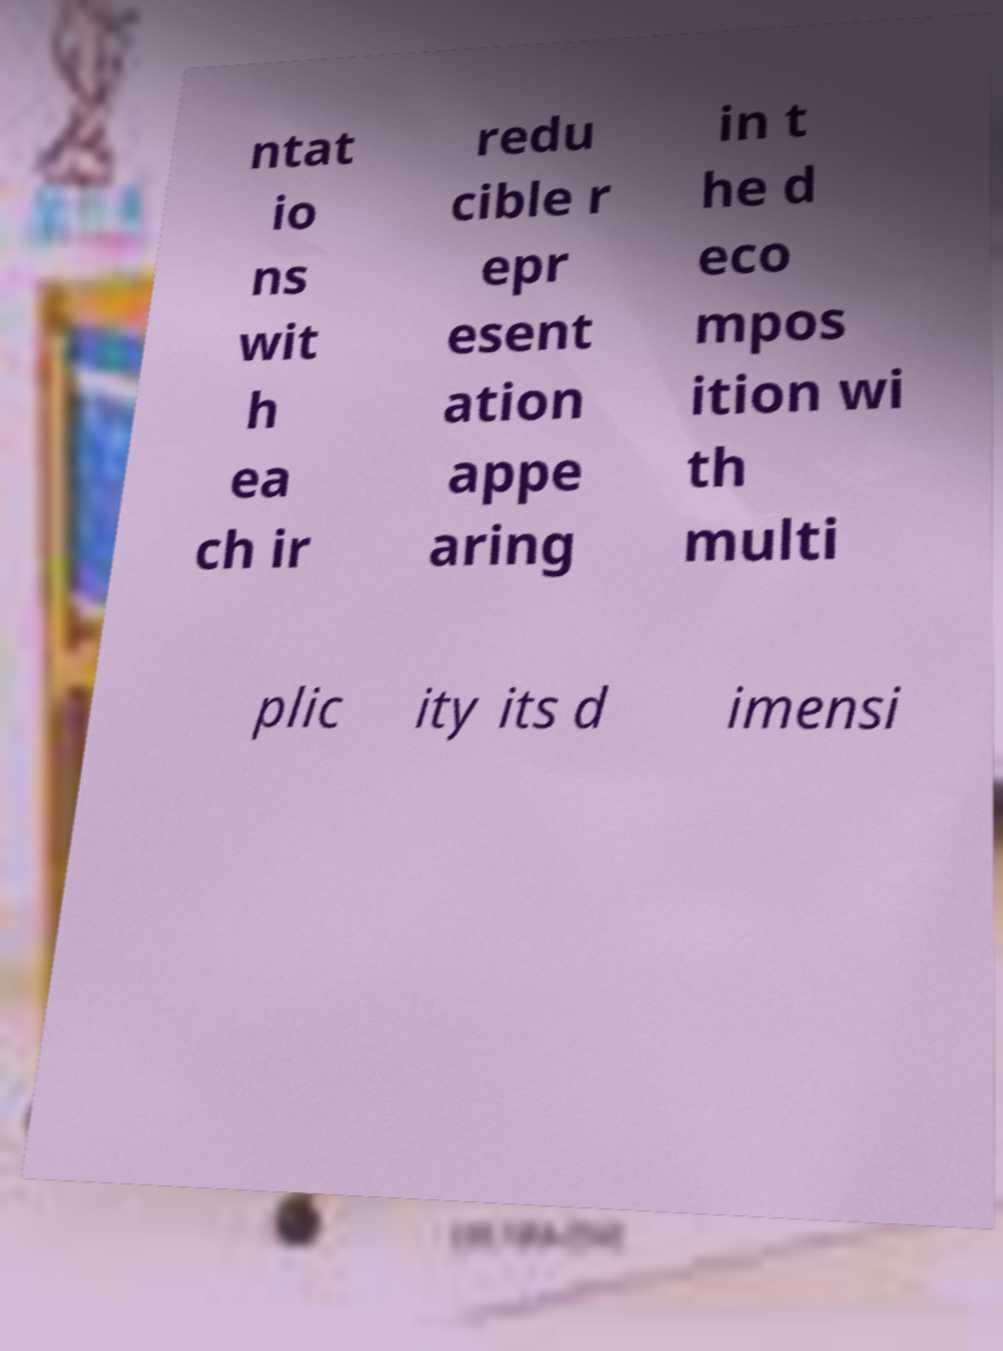What messages or text are displayed in this image? I need them in a readable, typed format. ntat io ns wit h ea ch ir redu cible r epr esent ation appe aring in t he d eco mpos ition wi th multi plic ity its d imensi 